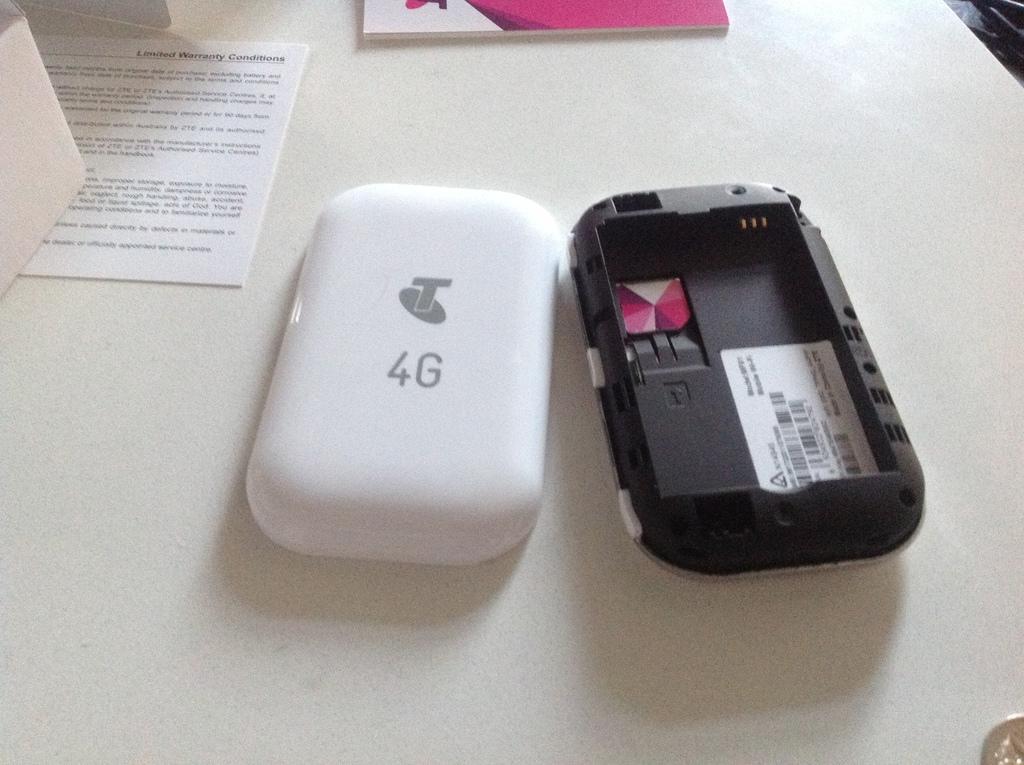Is this device 4g compatible?
Offer a very short reply. Yes. What kind of warranty condition is the top left booklet about?
Offer a very short reply. Limited. 